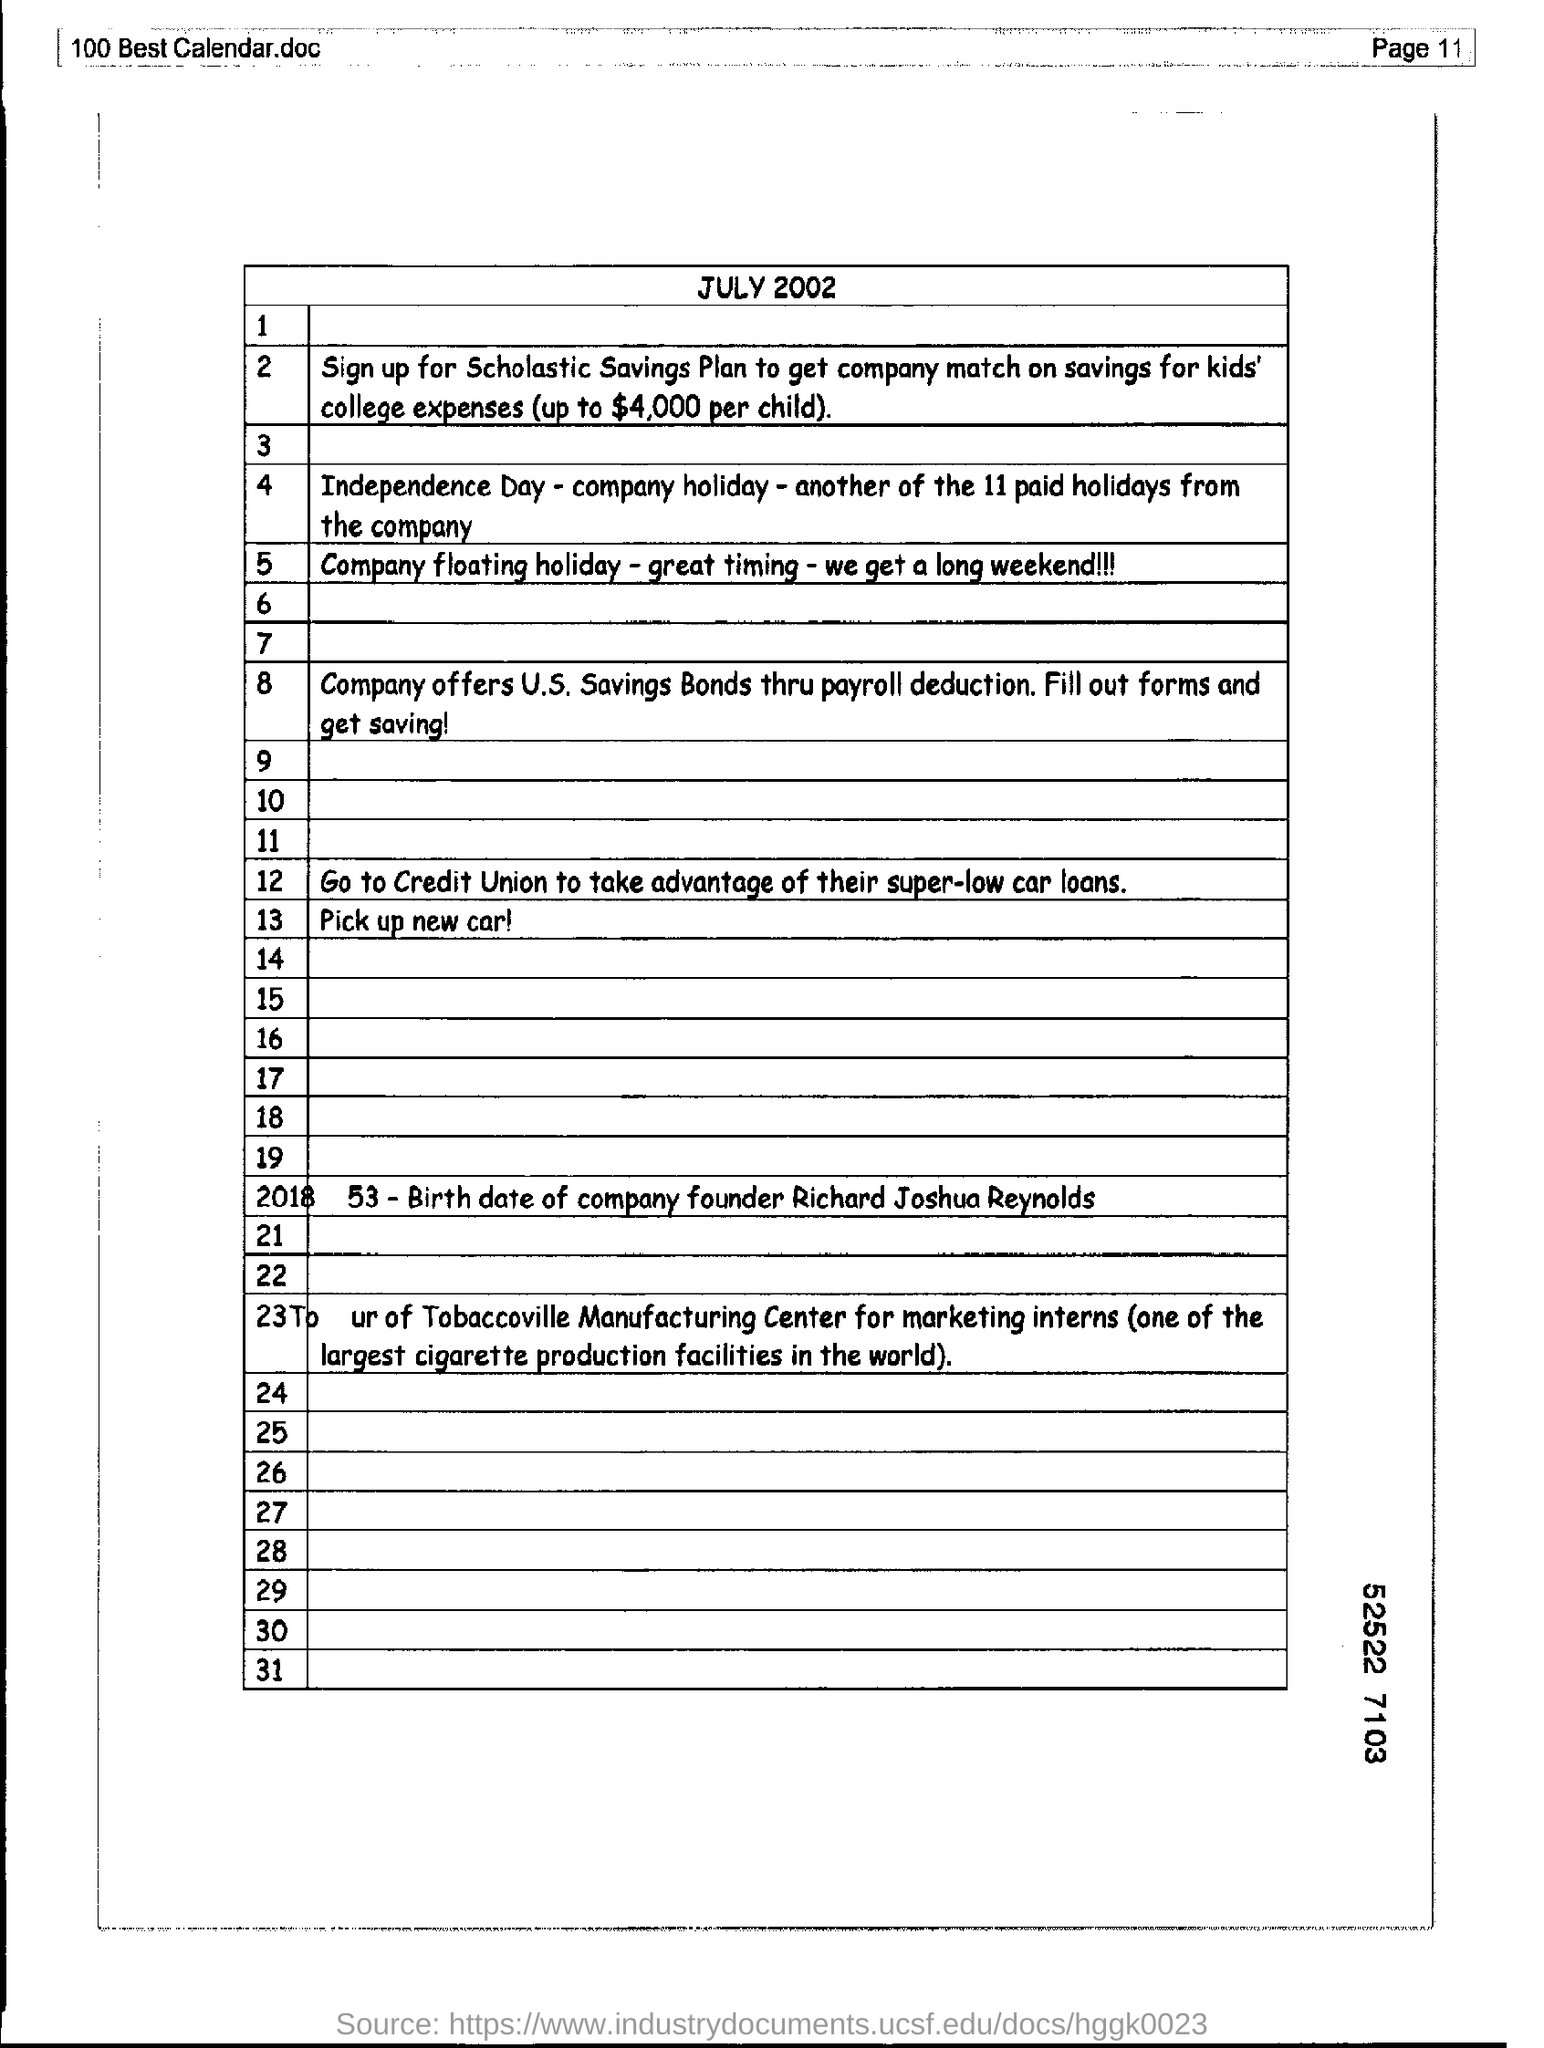Mention the page number at top right corner of the page ?
Ensure brevity in your answer.  11. What month and year are mentioned in the document ?
Ensure brevity in your answer.  July 2002. 